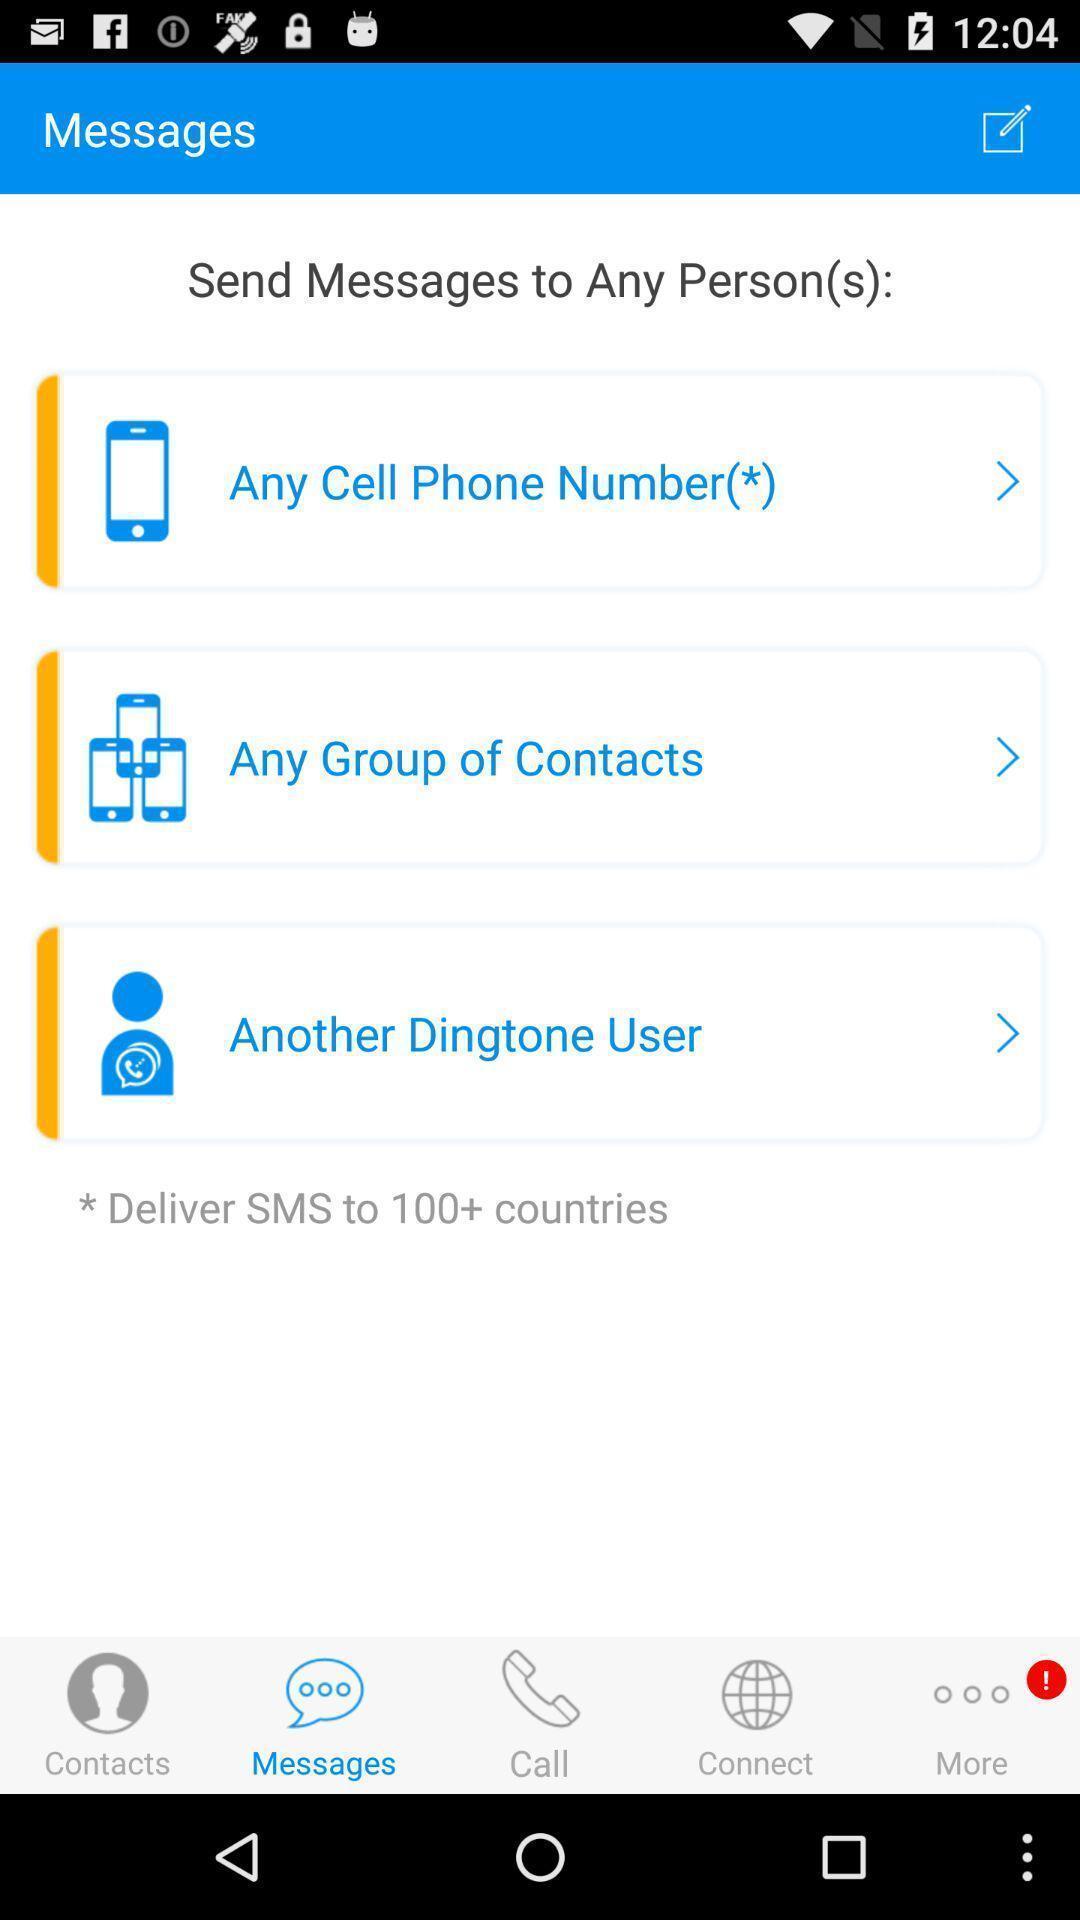What details can you identify in this image? Screen page displaying various options. 